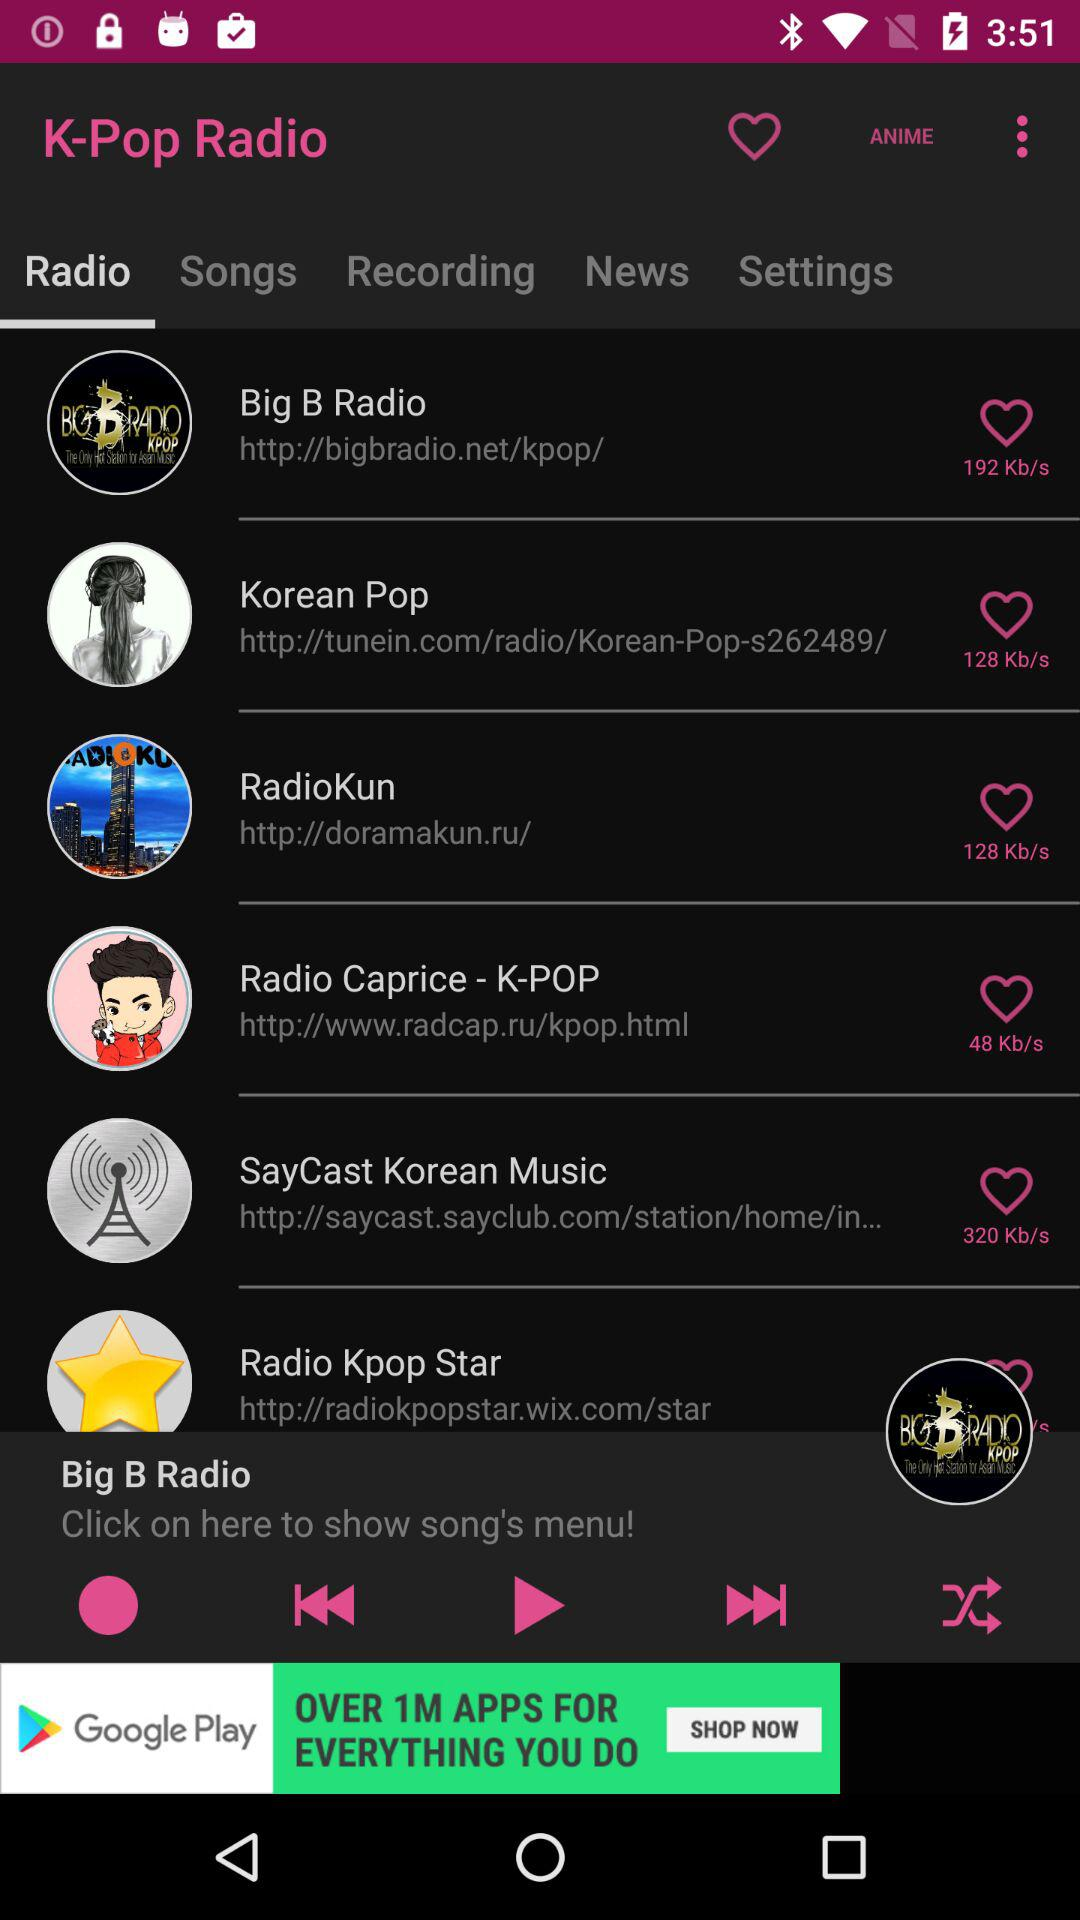Which radio station has a bitrate of 320 KB/s? The radio station "SayCast Korean Music" has a bitrate of 320 KB/s. 